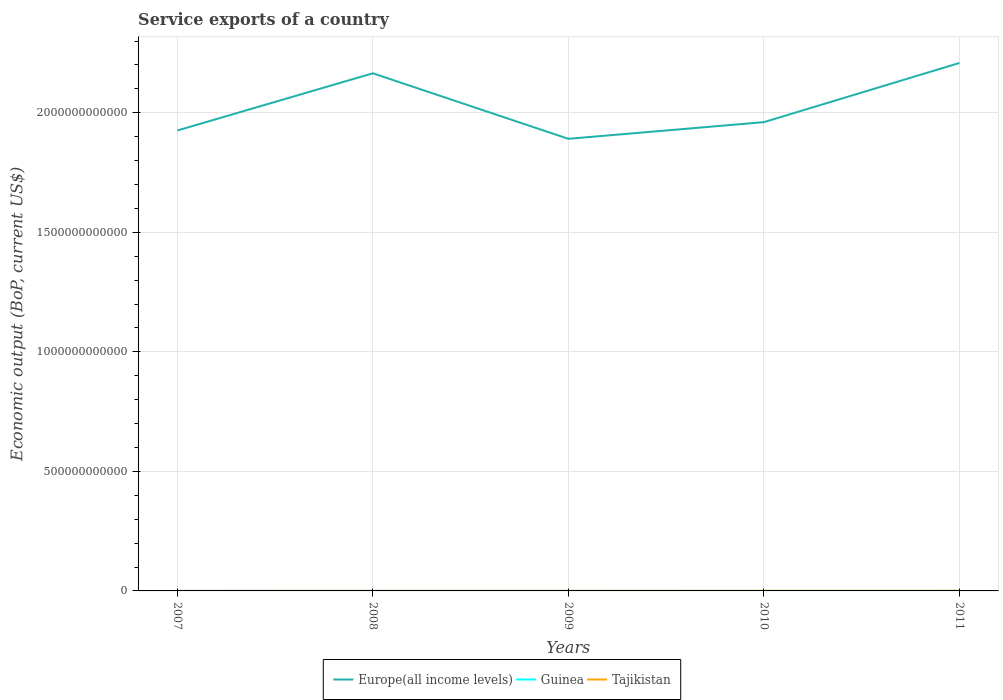Across all years, what is the maximum service exports in Guinea?
Keep it short and to the point. 4.87e+07. In which year was the service exports in Europe(all income levels) maximum?
Provide a short and direct response. 2009. What is the total service exports in Tajikistan in the graph?
Provide a succinct answer. -3.83e+08. What is the difference between the highest and the second highest service exports in Europe(all income levels)?
Offer a terse response. 3.17e+11. Is the service exports in Guinea strictly greater than the service exports in Europe(all income levels) over the years?
Offer a terse response. Yes. How many lines are there?
Give a very brief answer. 3. How many years are there in the graph?
Give a very brief answer. 5. What is the difference between two consecutive major ticks on the Y-axis?
Offer a terse response. 5.00e+11. Are the values on the major ticks of Y-axis written in scientific E-notation?
Your response must be concise. No. What is the title of the graph?
Make the answer very short. Service exports of a country. Does "Belize" appear as one of the legend labels in the graph?
Ensure brevity in your answer.  No. What is the label or title of the X-axis?
Keep it short and to the point. Years. What is the label or title of the Y-axis?
Make the answer very short. Economic output (BoP, current US$). What is the Economic output (BoP, current US$) of Europe(all income levels) in 2007?
Give a very brief answer. 1.93e+12. What is the Economic output (BoP, current US$) in Guinea in 2007?
Offer a terse response. 4.87e+07. What is the Economic output (BoP, current US$) of Tajikistan in 2007?
Make the answer very short. 1.49e+08. What is the Economic output (BoP, current US$) in Europe(all income levels) in 2008?
Provide a succinct answer. 2.17e+12. What is the Economic output (BoP, current US$) in Guinea in 2008?
Your answer should be very brief. 1.03e+08. What is the Economic output (BoP, current US$) in Tajikistan in 2008?
Ensure brevity in your answer.  1.81e+08. What is the Economic output (BoP, current US$) of Europe(all income levels) in 2009?
Offer a very short reply. 1.89e+12. What is the Economic output (BoP, current US$) of Guinea in 2009?
Provide a succinct answer. 7.22e+07. What is the Economic output (BoP, current US$) of Tajikistan in 2009?
Give a very brief answer. 1.80e+08. What is the Economic output (BoP, current US$) in Europe(all income levels) in 2010?
Your response must be concise. 1.96e+12. What is the Economic output (BoP, current US$) in Guinea in 2010?
Give a very brief answer. 6.24e+07. What is the Economic output (BoP, current US$) of Tajikistan in 2010?
Offer a very short reply. 4.26e+08. What is the Economic output (BoP, current US$) of Europe(all income levels) in 2011?
Ensure brevity in your answer.  2.21e+12. What is the Economic output (BoP, current US$) in Guinea in 2011?
Your answer should be very brief. 7.74e+07. What is the Economic output (BoP, current US$) in Tajikistan in 2011?
Offer a very short reply. 5.64e+08. Across all years, what is the maximum Economic output (BoP, current US$) of Europe(all income levels)?
Provide a short and direct response. 2.21e+12. Across all years, what is the maximum Economic output (BoP, current US$) of Guinea?
Offer a terse response. 1.03e+08. Across all years, what is the maximum Economic output (BoP, current US$) of Tajikistan?
Offer a very short reply. 5.64e+08. Across all years, what is the minimum Economic output (BoP, current US$) in Europe(all income levels)?
Make the answer very short. 1.89e+12. Across all years, what is the minimum Economic output (BoP, current US$) in Guinea?
Keep it short and to the point. 4.87e+07. Across all years, what is the minimum Economic output (BoP, current US$) of Tajikistan?
Your answer should be compact. 1.49e+08. What is the total Economic output (BoP, current US$) in Europe(all income levels) in the graph?
Keep it short and to the point. 1.02e+13. What is the total Economic output (BoP, current US$) of Guinea in the graph?
Make the answer very short. 3.64e+08. What is the total Economic output (BoP, current US$) in Tajikistan in the graph?
Offer a very short reply. 1.50e+09. What is the difference between the Economic output (BoP, current US$) in Europe(all income levels) in 2007 and that in 2008?
Ensure brevity in your answer.  -2.39e+11. What is the difference between the Economic output (BoP, current US$) in Guinea in 2007 and that in 2008?
Ensure brevity in your answer.  -5.42e+07. What is the difference between the Economic output (BoP, current US$) in Tajikistan in 2007 and that in 2008?
Keep it short and to the point. -3.27e+07. What is the difference between the Economic output (BoP, current US$) of Europe(all income levels) in 2007 and that in 2009?
Offer a terse response. 3.47e+1. What is the difference between the Economic output (BoP, current US$) of Guinea in 2007 and that in 2009?
Provide a short and direct response. -2.35e+07. What is the difference between the Economic output (BoP, current US$) in Tajikistan in 2007 and that in 2009?
Ensure brevity in your answer.  -3.11e+07. What is the difference between the Economic output (BoP, current US$) of Europe(all income levels) in 2007 and that in 2010?
Your answer should be compact. -3.50e+1. What is the difference between the Economic output (BoP, current US$) of Guinea in 2007 and that in 2010?
Ensure brevity in your answer.  -1.37e+07. What is the difference between the Economic output (BoP, current US$) in Tajikistan in 2007 and that in 2010?
Ensure brevity in your answer.  -2.77e+08. What is the difference between the Economic output (BoP, current US$) of Europe(all income levels) in 2007 and that in 2011?
Keep it short and to the point. -2.83e+11. What is the difference between the Economic output (BoP, current US$) in Guinea in 2007 and that in 2011?
Keep it short and to the point. -2.87e+07. What is the difference between the Economic output (BoP, current US$) in Tajikistan in 2007 and that in 2011?
Ensure brevity in your answer.  -4.16e+08. What is the difference between the Economic output (BoP, current US$) of Europe(all income levels) in 2008 and that in 2009?
Keep it short and to the point. 2.74e+11. What is the difference between the Economic output (BoP, current US$) in Guinea in 2008 and that in 2009?
Your answer should be compact. 3.07e+07. What is the difference between the Economic output (BoP, current US$) in Tajikistan in 2008 and that in 2009?
Offer a very short reply. 1.66e+06. What is the difference between the Economic output (BoP, current US$) in Europe(all income levels) in 2008 and that in 2010?
Offer a very short reply. 2.04e+11. What is the difference between the Economic output (BoP, current US$) in Guinea in 2008 and that in 2010?
Ensure brevity in your answer.  4.05e+07. What is the difference between the Economic output (BoP, current US$) in Tajikistan in 2008 and that in 2010?
Make the answer very short. -2.44e+08. What is the difference between the Economic output (BoP, current US$) in Europe(all income levels) in 2008 and that in 2011?
Your response must be concise. -4.32e+1. What is the difference between the Economic output (BoP, current US$) of Guinea in 2008 and that in 2011?
Ensure brevity in your answer.  2.55e+07. What is the difference between the Economic output (BoP, current US$) of Tajikistan in 2008 and that in 2011?
Provide a short and direct response. -3.83e+08. What is the difference between the Economic output (BoP, current US$) of Europe(all income levels) in 2009 and that in 2010?
Offer a very short reply. -6.97e+1. What is the difference between the Economic output (BoP, current US$) in Guinea in 2009 and that in 2010?
Make the answer very short. 9.83e+06. What is the difference between the Economic output (BoP, current US$) in Tajikistan in 2009 and that in 2010?
Provide a short and direct response. -2.46e+08. What is the difference between the Economic output (BoP, current US$) in Europe(all income levels) in 2009 and that in 2011?
Keep it short and to the point. -3.17e+11. What is the difference between the Economic output (BoP, current US$) in Guinea in 2009 and that in 2011?
Keep it short and to the point. -5.14e+06. What is the difference between the Economic output (BoP, current US$) of Tajikistan in 2009 and that in 2011?
Offer a terse response. -3.85e+08. What is the difference between the Economic output (BoP, current US$) in Europe(all income levels) in 2010 and that in 2011?
Offer a terse response. -2.48e+11. What is the difference between the Economic output (BoP, current US$) in Guinea in 2010 and that in 2011?
Keep it short and to the point. -1.50e+07. What is the difference between the Economic output (BoP, current US$) in Tajikistan in 2010 and that in 2011?
Keep it short and to the point. -1.39e+08. What is the difference between the Economic output (BoP, current US$) of Europe(all income levels) in 2007 and the Economic output (BoP, current US$) of Guinea in 2008?
Your response must be concise. 1.93e+12. What is the difference between the Economic output (BoP, current US$) of Europe(all income levels) in 2007 and the Economic output (BoP, current US$) of Tajikistan in 2008?
Make the answer very short. 1.93e+12. What is the difference between the Economic output (BoP, current US$) in Guinea in 2007 and the Economic output (BoP, current US$) in Tajikistan in 2008?
Provide a short and direct response. -1.33e+08. What is the difference between the Economic output (BoP, current US$) in Europe(all income levels) in 2007 and the Economic output (BoP, current US$) in Guinea in 2009?
Keep it short and to the point. 1.93e+12. What is the difference between the Economic output (BoP, current US$) in Europe(all income levels) in 2007 and the Economic output (BoP, current US$) in Tajikistan in 2009?
Ensure brevity in your answer.  1.93e+12. What is the difference between the Economic output (BoP, current US$) of Guinea in 2007 and the Economic output (BoP, current US$) of Tajikistan in 2009?
Keep it short and to the point. -1.31e+08. What is the difference between the Economic output (BoP, current US$) of Europe(all income levels) in 2007 and the Economic output (BoP, current US$) of Guinea in 2010?
Offer a very short reply. 1.93e+12. What is the difference between the Economic output (BoP, current US$) in Europe(all income levels) in 2007 and the Economic output (BoP, current US$) in Tajikistan in 2010?
Offer a very short reply. 1.93e+12. What is the difference between the Economic output (BoP, current US$) of Guinea in 2007 and the Economic output (BoP, current US$) of Tajikistan in 2010?
Your response must be concise. -3.77e+08. What is the difference between the Economic output (BoP, current US$) of Europe(all income levels) in 2007 and the Economic output (BoP, current US$) of Guinea in 2011?
Offer a very short reply. 1.93e+12. What is the difference between the Economic output (BoP, current US$) in Europe(all income levels) in 2007 and the Economic output (BoP, current US$) in Tajikistan in 2011?
Ensure brevity in your answer.  1.93e+12. What is the difference between the Economic output (BoP, current US$) of Guinea in 2007 and the Economic output (BoP, current US$) of Tajikistan in 2011?
Ensure brevity in your answer.  -5.16e+08. What is the difference between the Economic output (BoP, current US$) of Europe(all income levels) in 2008 and the Economic output (BoP, current US$) of Guinea in 2009?
Your answer should be very brief. 2.17e+12. What is the difference between the Economic output (BoP, current US$) of Europe(all income levels) in 2008 and the Economic output (BoP, current US$) of Tajikistan in 2009?
Give a very brief answer. 2.17e+12. What is the difference between the Economic output (BoP, current US$) in Guinea in 2008 and the Economic output (BoP, current US$) in Tajikistan in 2009?
Your answer should be compact. -7.68e+07. What is the difference between the Economic output (BoP, current US$) of Europe(all income levels) in 2008 and the Economic output (BoP, current US$) of Guinea in 2010?
Offer a terse response. 2.17e+12. What is the difference between the Economic output (BoP, current US$) in Europe(all income levels) in 2008 and the Economic output (BoP, current US$) in Tajikistan in 2010?
Offer a very short reply. 2.16e+12. What is the difference between the Economic output (BoP, current US$) of Guinea in 2008 and the Economic output (BoP, current US$) of Tajikistan in 2010?
Provide a succinct answer. -3.23e+08. What is the difference between the Economic output (BoP, current US$) in Europe(all income levels) in 2008 and the Economic output (BoP, current US$) in Guinea in 2011?
Your response must be concise. 2.17e+12. What is the difference between the Economic output (BoP, current US$) of Europe(all income levels) in 2008 and the Economic output (BoP, current US$) of Tajikistan in 2011?
Ensure brevity in your answer.  2.16e+12. What is the difference between the Economic output (BoP, current US$) in Guinea in 2008 and the Economic output (BoP, current US$) in Tajikistan in 2011?
Offer a terse response. -4.62e+08. What is the difference between the Economic output (BoP, current US$) in Europe(all income levels) in 2009 and the Economic output (BoP, current US$) in Guinea in 2010?
Make the answer very short. 1.89e+12. What is the difference between the Economic output (BoP, current US$) of Europe(all income levels) in 2009 and the Economic output (BoP, current US$) of Tajikistan in 2010?
Keep it short and to the point. 1.89e+12. What is the difference between the Economic output (BoP, current US$) of Guinea in 2009 and the Economic output (BoP, current US$) of Tajikistan in 2010?
Offer a terse response. -3.53e+08. What is the difference between the Economic output (BoP, current US$) of Europe(all income levels) in 2009 and the Economic output (BoP, current US$) of Guinea in 2011?
Your answer should be compact. 1.89e+12. What is the difference between the Economic output (BoP, current US$) of Europe(all income levels) in 2009 and the Economic output (BoP, current US$) of Tajikistan in 2011?
Ensure brevity in your answer.  1.89e+12. What is the difference between the Economic output (BoP, current US$) in Guinea in 2009 and the Economic output (BoP, current US$) in Tajikistan in 2011?
Make the answer very short. -4.92e+08. What is the difference between the Economic output (BoP, current US$) in Europe(all income levels) in 2010 and the Economic output (BoP, current US$) in Guinea in 2011?
Your response must be concise. 1.96e+12. What is the difference between the Economic output (BoP, current US$) in Europe(all income levels) in 2010 and the Economic output (BoP, current US$) in Tajikistan in 2011?
Provide a short and direct response. 1.96e+12. What is the difference between the Economic output (BoP, current US$) in Guinea in 2010 and the Economic output (BoP, current US$) in Tajikistan in 2011?
Your response must be concise. -5.02e+08. What is the average Economic output (BoP, current US$) of Europe(all income levels) per year?
Keep it short and to the point. 2.03e+12. What is the average Economic output (BoP, current US$) in Guinea per year?
Ensure brevity in your answer.  7.27e+07. What is the average Economic output (BoP, current US$) of Tajikistan per year?
Ensure brevity in your answer.  3.00e+08. In the year 2007, what is the difference between the Economic output (BoP, current US$) in Europe(all income levels) and Economic output (BoP, current US$) in Guinea?
Offer a terse response. 1.93e+12. In the year 2007, what is the difference between the Economic output (BoP, current US$) in Europe(all income levels) and Economic output (BoP, current US$) in Tajikistan?
Give a very brief answer. 1.93e+12. In the year 2007, what is the difference between the Economic output (BoP, current US$) of Guinea and Economic output (BoP, current US$) of Tajikistan?
Make the answer very short. -1.00e+08. In the year 2008, what is the difference between the Economic output (BoP, current US$) of Europe(all income levels) and Economic output (BoP, current US$) of Guinea?
Your answer should be compact. 2.17e+12. In the year 2008, what is the difference between the Economic output (BoP, current US$) in Europe(all income levels) and Economic output (BoP, current US$) in Tajikistan?
Your answer should be compact. 2.17e+12. In the year 2008, what is the difference between the Economic output (BoP, current US$) in Guinea and Economic output (BoP, current US$) in Tajikistan?
Offer a terse response. -7.85e+07. In the year 2009, what is the difference between the Economic output (BoP, current US$) of Europe(all income levels) and Economic output (BoP, current US$) of Guinea?
Provide a succinct answer. 1.89e+12. In the year 2009, what is the difference between the Economic output (BoP, current US$) of Europe(all income levels) and Economic output (BoP, current US$) of Tajikistan?
Ensure brevity in your answer.  1.89e+12. In the year 2009, what is the difference between the Economic output (BoP, current US$) of Guinea and Economic output (BoP, current US$) of Tajikistan?
Ensure brevity in your answer.  -1.08e+08. In the year 2010, what is the difference between the Economic output (BoP, current US$) in Europe(all income levels) and Economic output (BoP, current US$) in Guinea?
Provide a short and direct response. 1.96e+12. In the year 2010, what is the difference between the Economic output (BoP, current US$) of Europe(all income levels) and Economic output (BoP, current US$) of Tajikistan?
Provide a succinct answer. 1.96e+12. In the year 2010, what is the difference between the Economic output (BoP, current US$) in Guinea and Economic output (BoP, current US$) in Tajikistan?
Give a very brief answer. -3.63e+08. In the year 2011, what is the difference between the Economic output (BoP, current US$) in Europe(all income levels) and Economic output (BoP, current US$) in Guinea?
Keep it short and to the point. 2.21e+12. In the year 2011, what is the difference between the Economic output (BoP, current US$) in Europe(all income levels) and Economic output (BoP, current US$) in Tajikistan?
Keep it short and to the point. 2.21e+12. In the year 2011, what is the difference between the Economic output (BoP, current US$) in Guinea and Economic output (BoP, current US$) in Tajikistan?
Offer a terse response. -4.87e+08. What is the ratio of the Economic output (BoP, current US$) of Europe(all income levels) in 2007 to that in 2008?
Offer a terse response. 0.89. What is the ratio of the Economic output (BoP, current US$) of Guinea in 2007 to that in 2008?
Ensure brevity in your answer.  0.47. What is the ratio of the Economic output (BoP, current US$) of Tajikistan in 2007 to that in 2008?
Provide a succinct answer. 0.82. What is the ratio of the Economic output (BoP, current US$) of Europe(all income levels) in 2007 to that in 2009?
Your answer should be compact. 1.02. What is the ratio of the Economic output (BoP, current US$) in Guinea in 2007 to that in 2009?
Make the answer very short. 0.67. What is the ratio of the Economic output (BoP, current US$) in Tajikistan in 2007 to that in 2009?
Offer a very short reply. 0.83. What is the ratio of the Economic output (BoP, current US$) in Europe(all income levels) in 2007 to that in 2010?
Your answer should be compact. 0.98. What is the ratio of the Economic output (BoP, current US$) in Guinea in 2007 to that in 2010?
Your answer should be very brief. 0.78. What is the ratio of the Economic output (BoP, current US$) in Tajikistan in 2007 to that in 2010?
Your answer should be very brief. 0.35. What is the ratio of the Economic output (BoP, current US$) in Europe(all income levels) in 2007 to that in 2011?
Keep it short and to the point. 0.87. What is the ratio of the Economic output (BoP, current US$) of Guinea in 2007 to that in 2011?
Provide a succinct answer. 0.63. What is the ratio of the Economic output (BoP, current US$) of Tajikistan in 2007 to that in 2011?
Make the answer very short. 0.26. What is the ratio of the Economic output (BoP, current US$) in Europe(all income levels) in 2008 to that in 2009?
Provide a succinct answer. 1.14. What is the ratio of the Economic output (BoP, current US$) in Guinea in 2008 to that in 2009?
Make the answer very short. 1.42. What is the ratio of the Economic output (BoP, current US$) in Tajikistan in 2008 to that in 2009?
Offer a very short reply. 1.01. What is the ratio of the Economic output (BoP, current US$) in Europe(all income levels) in 2008 to that in 2010?
Give a very brief answer. 1.1. What is the ratio of the Economic output (BoP, current US$) of Guinea in 2008 to that in 2010?
Your answer should be very brief. 1.65. What is the ratio of the Economic output (BoP, current US$) of Tajikistan in 2008 to that in 2010?
Provide a succinct answer. 0.43. What is the ratio of the Economic output (BoP, current US$) of Europe(all income levels) in 2008 to that in 2011?
Your answer should be compact. 0.98. What is the ratio of the Economic output (BoP, current US$) in Guinea in 2008 to that in 2011?
Offer a terse response. 1.33. What is the ratio of the Economic output (BoP, current US$) of Tajikistan in 2008 to that in 2011?
Keep it short and to the point. 0.32. What is the ratio of the Economic output (BoP, current US$) of Europe(all income levels) in 2009 to that in 2010?
Provide a short and direct response. 0.96. What is the ratio of the Economic output (BoP, current US$) of Guinea in 2009 to that in 2010?
Provide a succinct answer. 1.16. What is the ratio of the Economic output (BoP, current US$) in Tajikistan in 2009 to that in 2010?
Your answer should be very brief. 0.42. What is the ratio of the Economic output (BoP, current US$) in Europe(all income levels) in 2009 to that in 2011?
Make the answer very short. 0.86. What is the ratio of the Economic output (BoP, current US$) of Guinea in 2009 to that in 2011?
Make the answer very short. 0.93. What is the ratio of the Economic output (BoP, current US$) of Tajikistan in 2009 to that in 2011?
Ensure brevity in your answer.  0.32. What is the ratio of the Economic output (BoP, current US$) in Europe(all income levels) in 2010 to that in 2011?
Give a very brief answer. 0.89. What is the ratio of the Economic output (BoP, current US$) of Guinea in 2010 to that in 2011?
Your answer should be compact. 0.81. What is the ratio of the Economic output (BoP, current US$) in Tajikistan in 2010 to that in 2011?
Offer a terse response. 0.75. What is the difference between the highest and the second highest Economic output (BoP, current US$) in Europe(all income levels)?
Your answer should be compact. 4.32e+1. What is the difference between the highest and the second highest Economic output (BoP, current US$) of Guinea?
Offer a terse response. 2.55e+07. What is the difference between the highest and the second highest Economic output (BoP, current US$) of Tajikistan?
Make the answer very short. 1.39e+08. What is the difference between the highest and the lowest Economic output (BoP, current US$) in Europe(all income levels)?
Provide a short and direct response. 3.17e+11. What is the difference between the highest and the lowest Economic output (BoP, current US$) in Guinea?
Offer a very short reply. 5.42e+07. What is the difference between the highest and the lowest Economic output (BoP, current US$) of Tajikistan?
Give a very brief answer. 4.16e+08. 